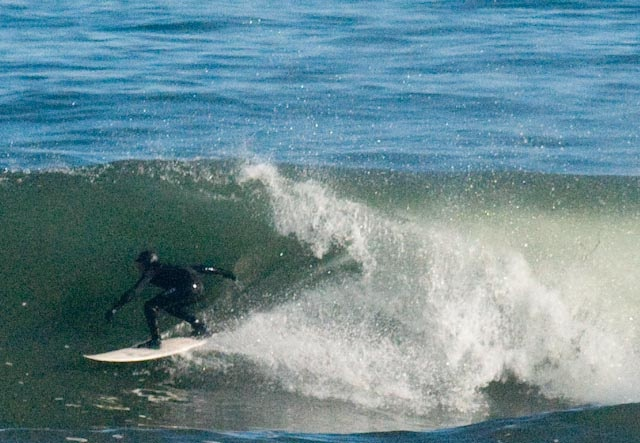Describe the objects in this image and their specific colors. I can see people in lightblue, black, purple, gray, and darkblue tones and surfboard in lightblue, lightgray, darkgray, and gray tones in this image. 